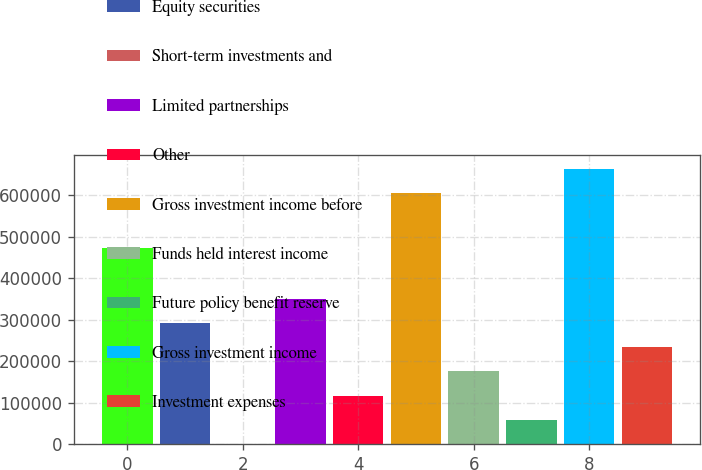Convert chart to OTSL. <chart><loc_0><loc_0><loc_500><loc_500><bar_chart><fcel>Fixed maturity securities<fcel>Equity securities<fcel>Short-term investments and<fcel>Limited partnerships<fcel>Other<fcel>Gross investment income before<fcel>Funds held interest income<fcel>Future policy benefit reserve<fcel>Gross investment income<fcel>Investment expenses<nl><fcel>473493<fcel>291782<fcel>1295<fcel>349879<fcel>117490<fcel>606606<fcel>175587<fcel>59392.3<fcel>664704<fcel>233684<nl></chart> 